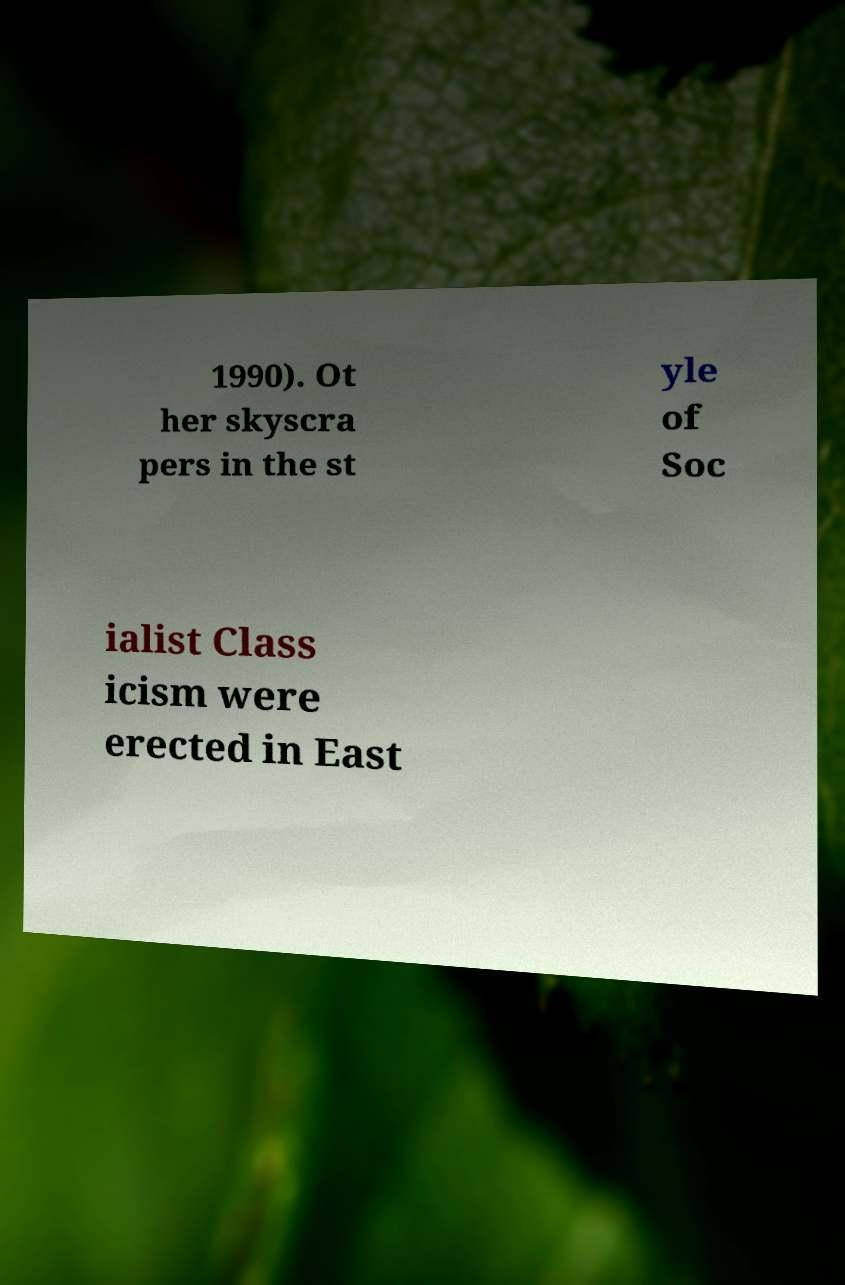For documentation purposes, I need the text within this image transcribed. Could you provide that? 1990). Ot her skyscra pers in the st yle of Soc ialist Class icism were erected in East 